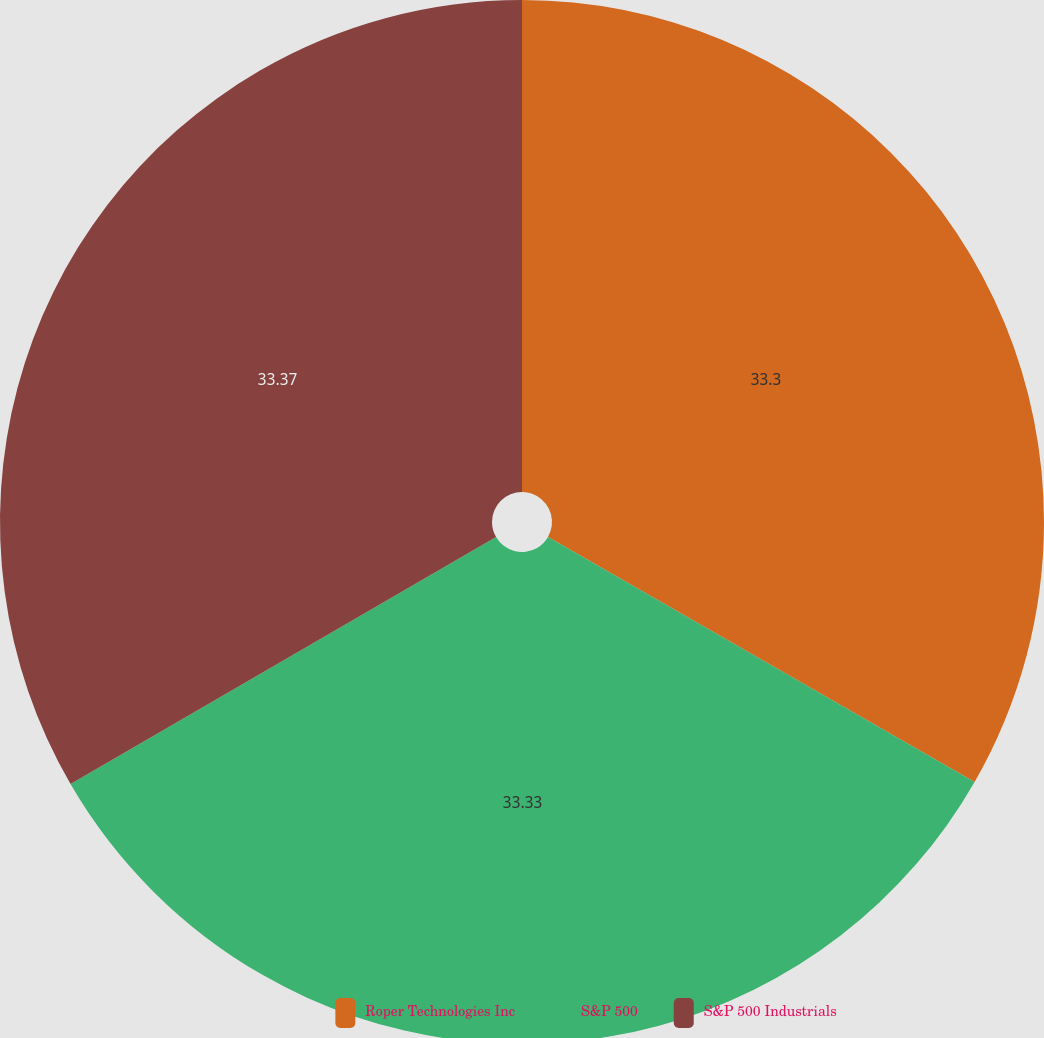Convert chart to OTSL. <chart><loc_0><loc_0><loc_500><loc_500><pie_chart><fcel>Roper Technologies Inc<fcel>S&P 500<fcel>S&P 500 Industrials<nl><fcel>33.3%<fcel>33.33%<fcel>33.37%<nl></chart> 